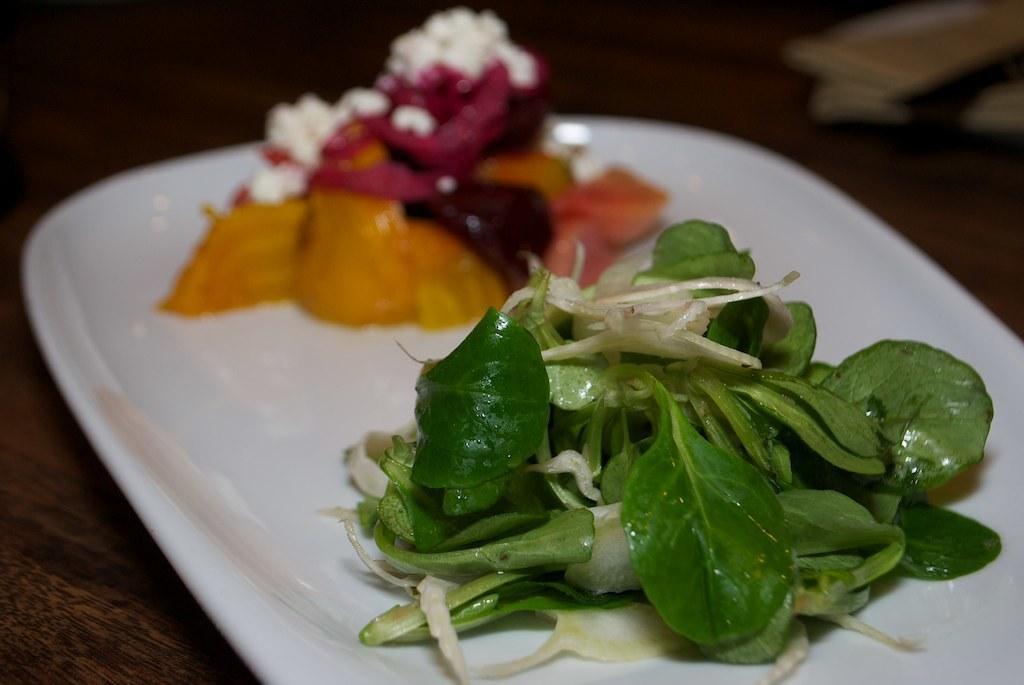How would you summarize this image in a sentence or two? In the picture I can see food items on a white color plate. The background of the image is blurred. 